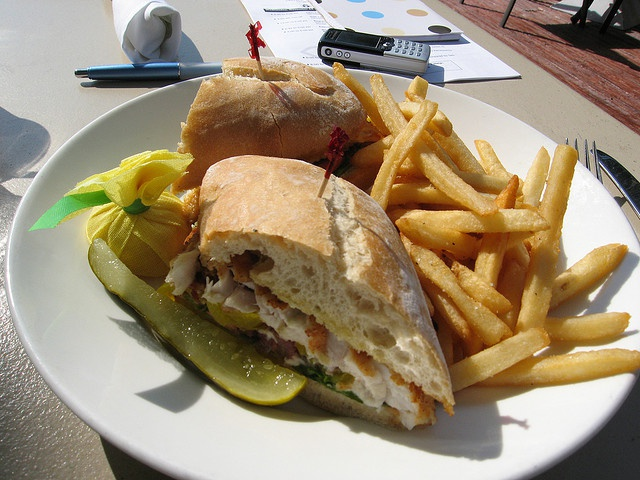Describe the objects in this image and their specific colors. I can see sandwich in lightgray, olive, gray, and tan tones, sandwich in lightgray, maroon, tan, and gray tones, cell phone in lightgray, black, darkgray, and gray tones, knife in lightgray, black, blue, and navy tones, and fork in lightgray, darkgray, gray, black, and tan tones in this image. 